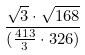Convert formula to latex. <formula><loc_0><loc_0><loc_500><loc_500>\frac { \sqrt { 3 } \cdot \sqrt { 1 6 8 } } { ( \frac { 4 1 3 } { 3 } \cdot 3 2 6 ) }</formula> 